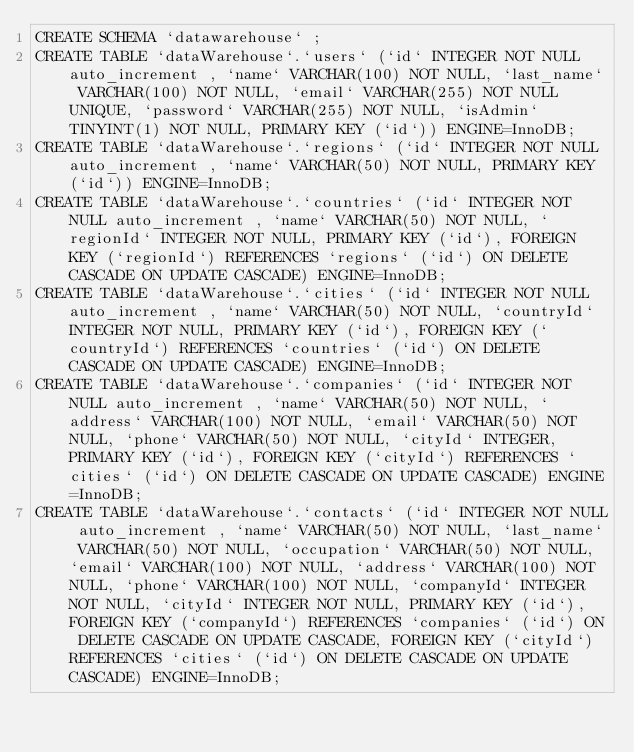<code> <loc_0><loc_0><loc_500><loc_500><_SQL_>CREATE SCHEMA `datawarehouse` ;
CREATE TABLE `dataWarehouse`.`users` (`id` INTEGER NOT NULL auto_increment , `name` VARCHAR(100) NOT NULL, `last_name` VARCHAR(100) NOT NULL, `email` VARCHAR(255) NOT NULL UNIQUE, `password` VARCHAR(255) NOT NULL, `isAdmin` TINYINT(1) NOT NULL, PRIMARY KEY (`id`)) ENGINE=InnoDB;
CREATE TABLE `dataWarehouse`.`regions` (`id` INTEGER NOT NULL auto_increment , `name` VARCHAR(50) NOT NULL, PRIMARY KEY (`id`)) ENGINE=InnoDB;
CREATE TABLE `dataWarehouse`.`countries` (`id` INTEGER NOT NULL auto_increment , `name` VARCHAR(50) NOT NULL, `regionId` INTEGER NOT NULL, PRIMARY KEY (`id`), FOREIGN KEY (`regionId`) REFERENCES `regions` (`id`) ON DELETE CASCADE ON UPDATE CASCADE) ENGINE=InnoDB;
CREATE TABLE `dataWarehouse`.`cities` (`id` INTEGER NOT NULL auto_increment , `name` VARCHAR(50) NOT NULL, `countryId` INTEGER NOT NULL, PRIMARY KEY (`id`), FOREIGN KEY (`countryId`) REFERENCES `countries` (`id`) ON DELETE CASCADE ON UPDATE CASCADE) ENGINE=InnoDB;
CREATE TABLE `dataWarehouse`.`companies` (`id` INTEGER NOT NULL auto_increment , `name` VARCHAR(50) NOT NULL, `address` VARCHAR(100) NOT NULL, `email` VARCHAR(50) NOT NULL, `phone` VARCHAR(50) NOT NULL, `cityId` INTEGER, PRIMARY KEY (`id`), FOREIGN KEY (`cityId`) REFERENCES `cities` (`id`) ON DELETE CASCADE ON UPDATE CASCADE) ENGINE=InnoDB;
CREATE TABLE `dataWarehouse`.`contacts` (`id` INTEGER NOT NULL auto_increment , `name` VARCHAR(50) NOT NULL, `last_name` VARCHAR(50) NOT NULL, `occupation` VARCHAR(50) NOT NULL, `email` VARCHAR(100) NOT NULL, `address` VARCHAR(100) NOT NULL, `phone` VARCHAR(100) NOT NULL, `companyId` INTEGER NOT NULL, `cityId` INTEGER NOT NULL, PRIMARY KEY (`id`), FOREIGN KEY (`companyId`) REFERENCES `companies` (`id`) ON DELETE CASCADE ON UPDATE CASCADE, FOREIGN KEY (`cityId`) REFERENCES `cities` (`id`) ON DELETE CASCADE ON UPDATE CASCADE) ENGINE=InnoDB;

</code> 